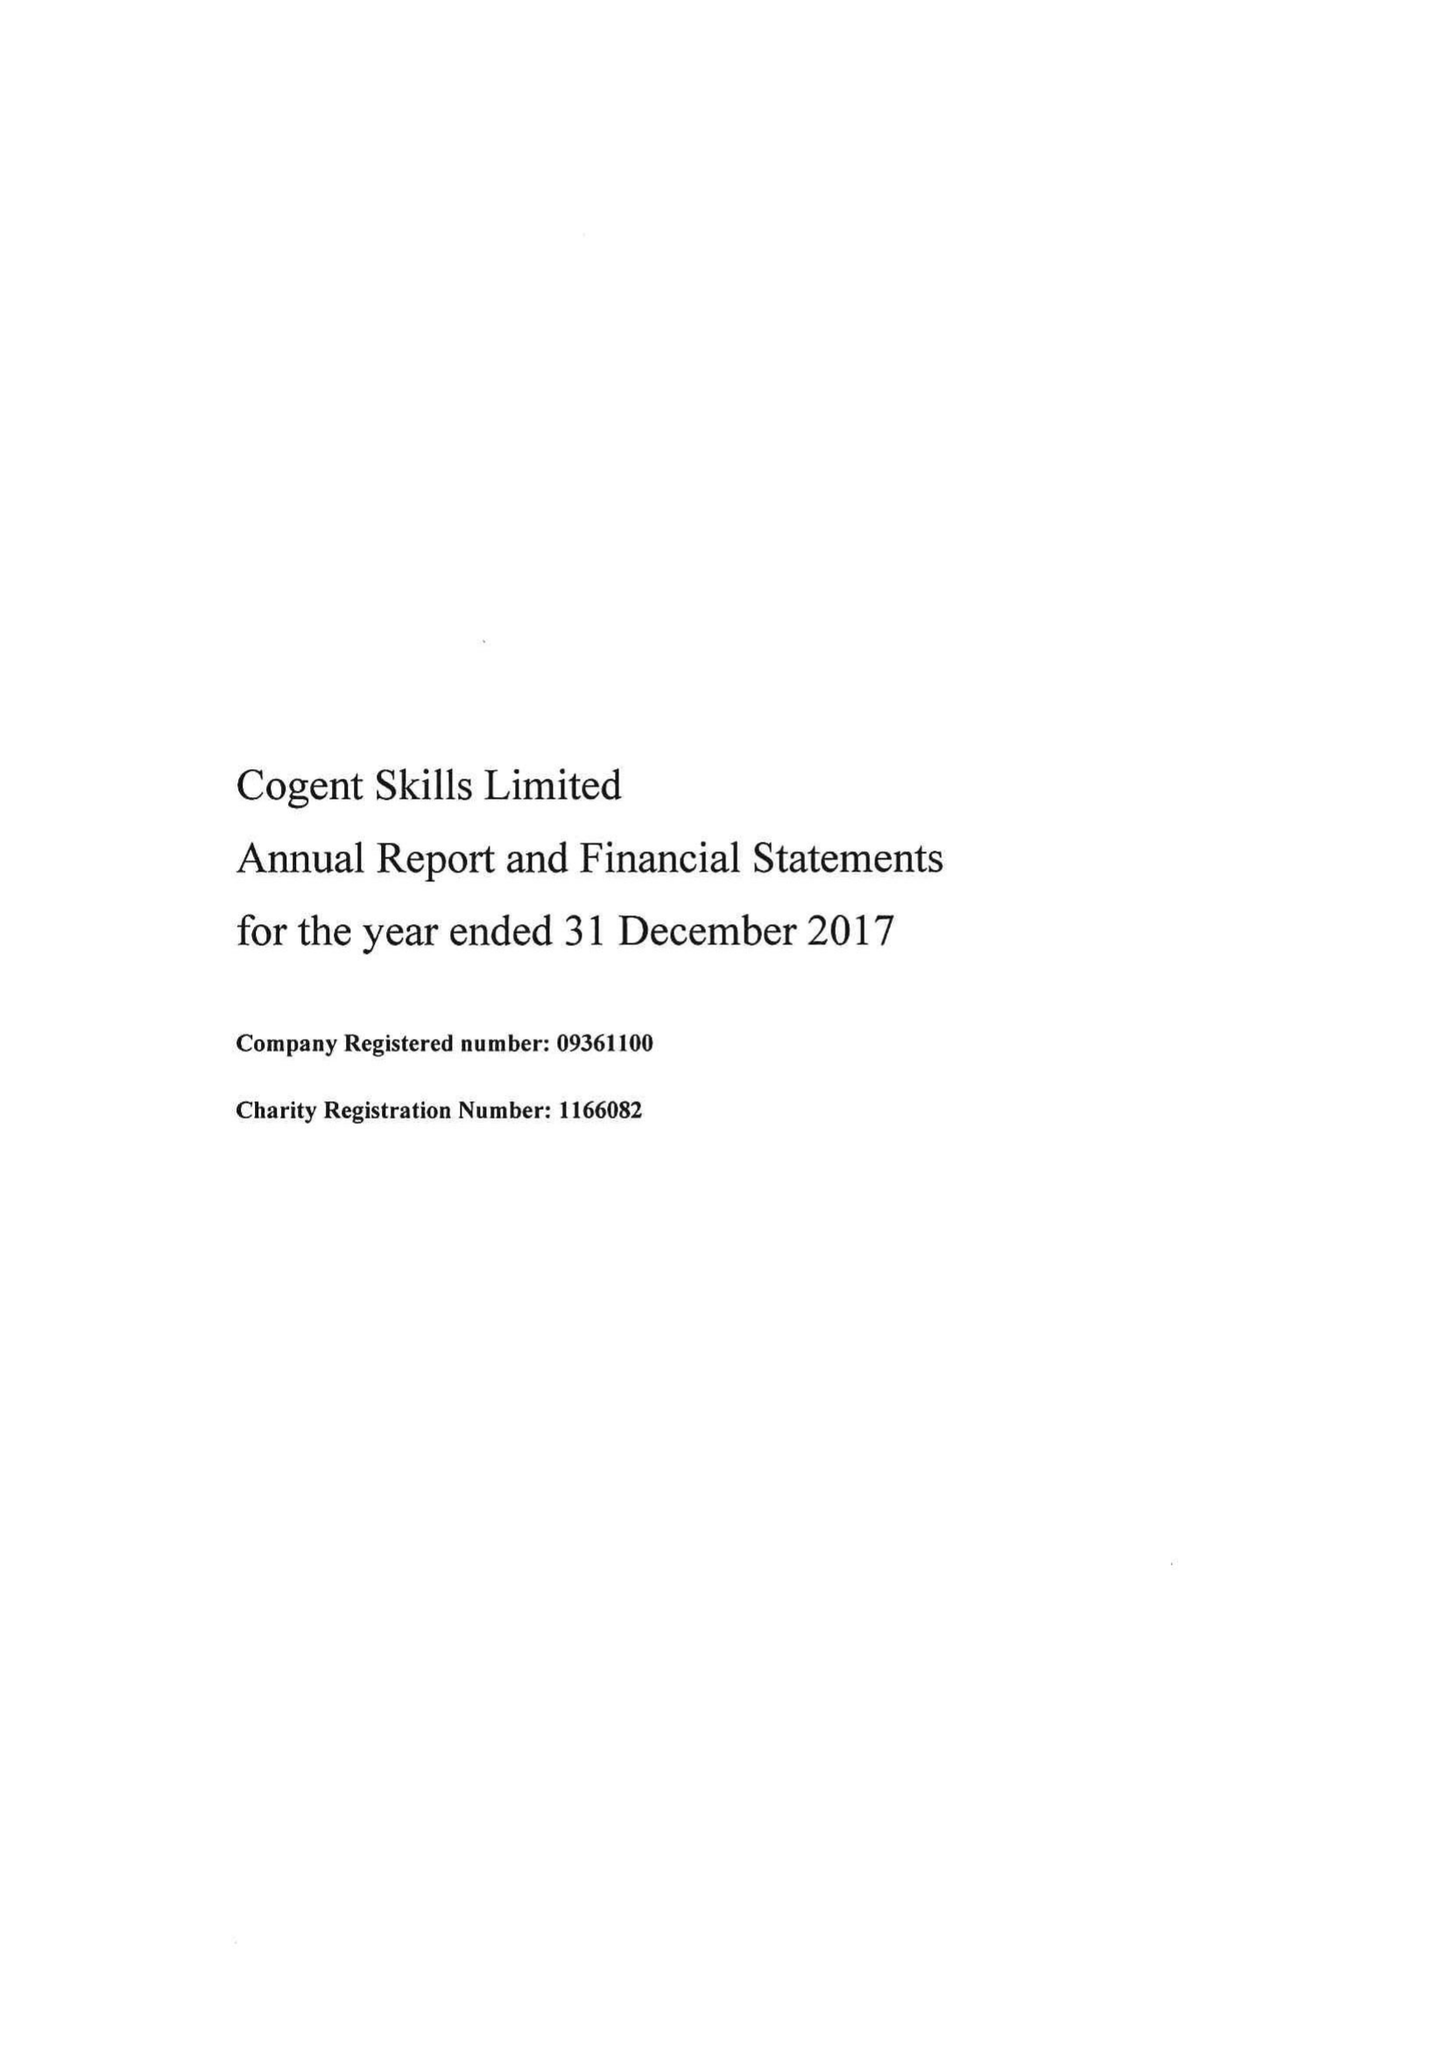What is the value for the report_date?
Answer the question using a single word or phrase. 2017-12-31 